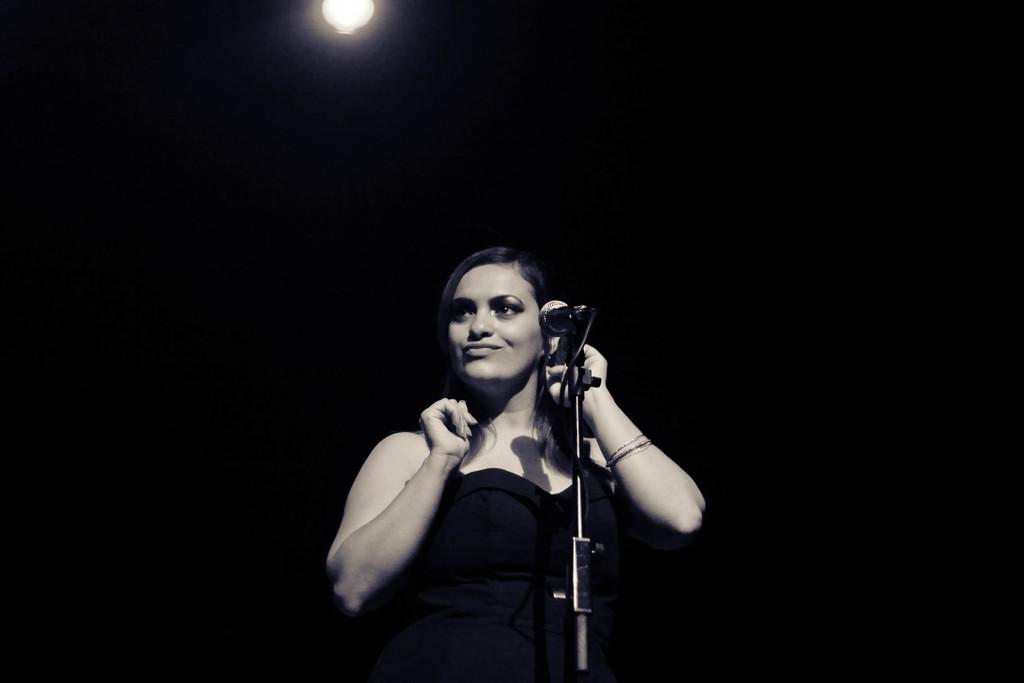What is the main subject of the image? There is a person standing in the image. What object is visible near the person? There is a mic in the image. What structure is present in the image? There is a stand in the image. What type of lighting is present in the image? There is a light in the image. What color is the background of the image? The background of the image is black. Can you see a crown on the person's head in the image? There is no crown visible on the person's head in the image. What type of observation can be made about the person's behavior in the image? The image does not provide any information about the person's behavior, so it is not possible to make an observation about it. 